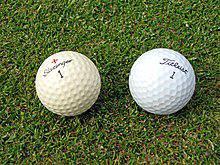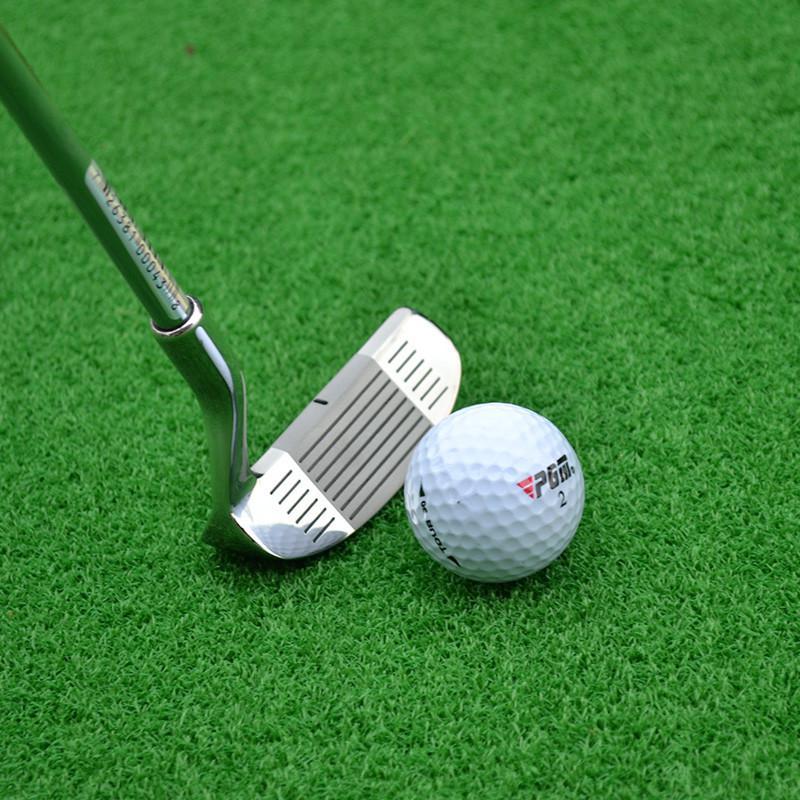The first image is the image on the left, the second image is the image on the right. Assess this claim about the two images: "Atleast one image of a person holding 2 balls behind their back". Correct or not? Answer yes or no. No. 